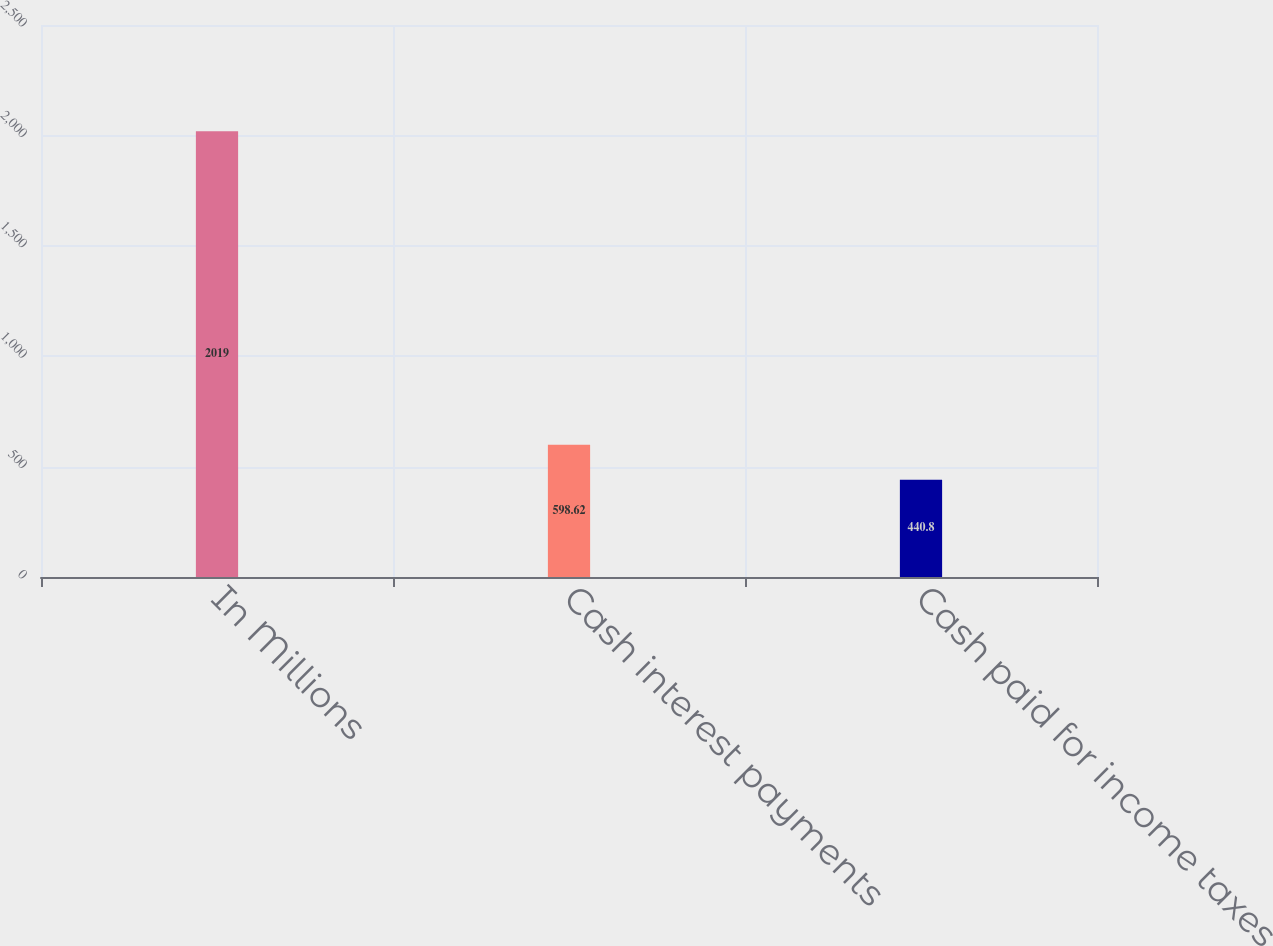Convert chart to OTSL. <chart><loc_0><loc_0><loc_500><loc_500><bar_chart><fcel>In Millions<fcel>Cash interest payments<fcel>Cash paid for income taxes<nl><fcel>2019<fcel>598.62<fcel>440.8<nl></chart> 